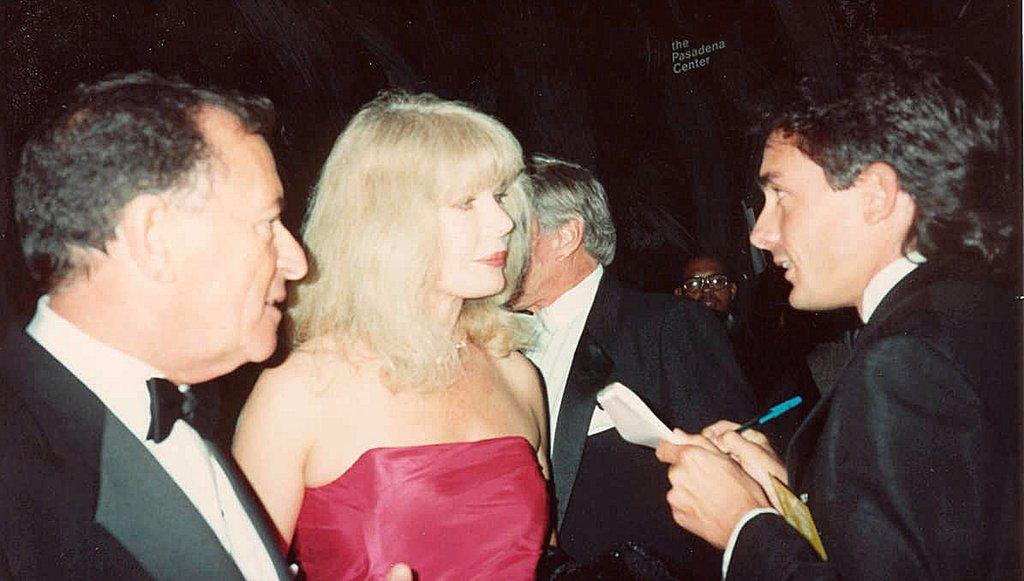How many people are in total are in the image? There is a group of persons in the image, but the exact number is not specified. What is one person in the foreground doing? A person is writing on paper in the foreground. What can be seen at the top of the image? There is text visible at the top of the image. How would you describe the lighting in the image? The background of the image is dark. What type of acoustics can be heard in the alley behind the group of persons in the image? There is no mention of an alley or any acoustics in the image, so it is not possible to answer that question. 